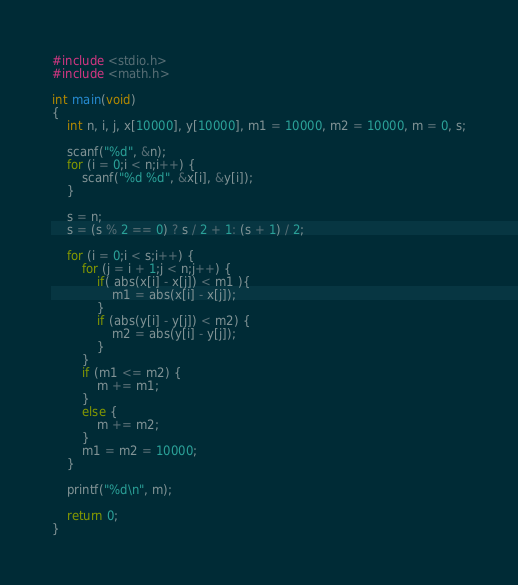<code> <loc_0><loc_0><loc_500><loc_500><_C_>#include <stdio.h>
#include <math.h>

int main(void)
{
	int n, i, j, x[10000], y[10000], m1 = 10000, m2 = 10000, m = 0, s;

	scanf("%d", &n);
	for (i = 0;i < n;i++) {
		scanf("%d %d", &x[i], &y[i]);
	}

	s = n;
	s = (s % 2 == 0) ? s / 2 + 1: (s + 1) / 2;

	for (i = 0;i < s;i++) {
		for (j = i + 1;j < n;j++) {
			if( abs(x[i] - x[j]) < m1 ){
				m1 = abs(x[i] - x[j]);
			}
			if (abs(y[i] - y[j]) < m2) {
				m2 = abs(y[i] - y[j]);
			}
		}
		if (m1 <= m2) {
			m += m1;
		}
		else {
			m += m2;
		}
		m1 = m2 = 10000;
	}

	printf("%d\n", m);

	return 0;
}</code> 